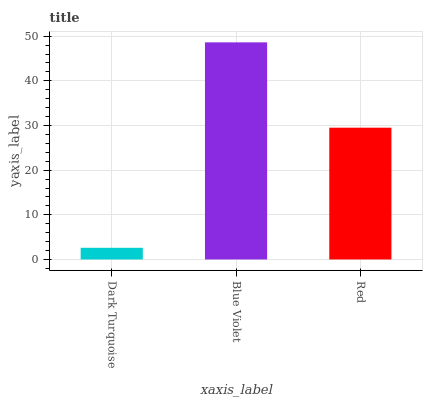Is Dark Turquoise the minimum?
Answer yes or no. Yes. Is Blue Violet the maximum?
Answer yes or no. Yes. Is Red the minimum?
Answer yes or no. No. Is Red the maximum?
Answer yes or no. No. Is Blue Violet greater than Red?
Answer yes or no. Yes. Is Red less than Blue Violet?
Answer yes or no. Yes. Is Red greater than Blue Violet?
Answer yes or no. No. Is Blue Violet less than Red?
Answer yes or no. No. Is Red the high median?
Answer yes or no. Yes. Is Red the low median?
Answer yes or no. Yes. Is Blue Violet the high median?
Answer yes or no. No. Is Blue Violet the low median?
Answer yes or no. No. 